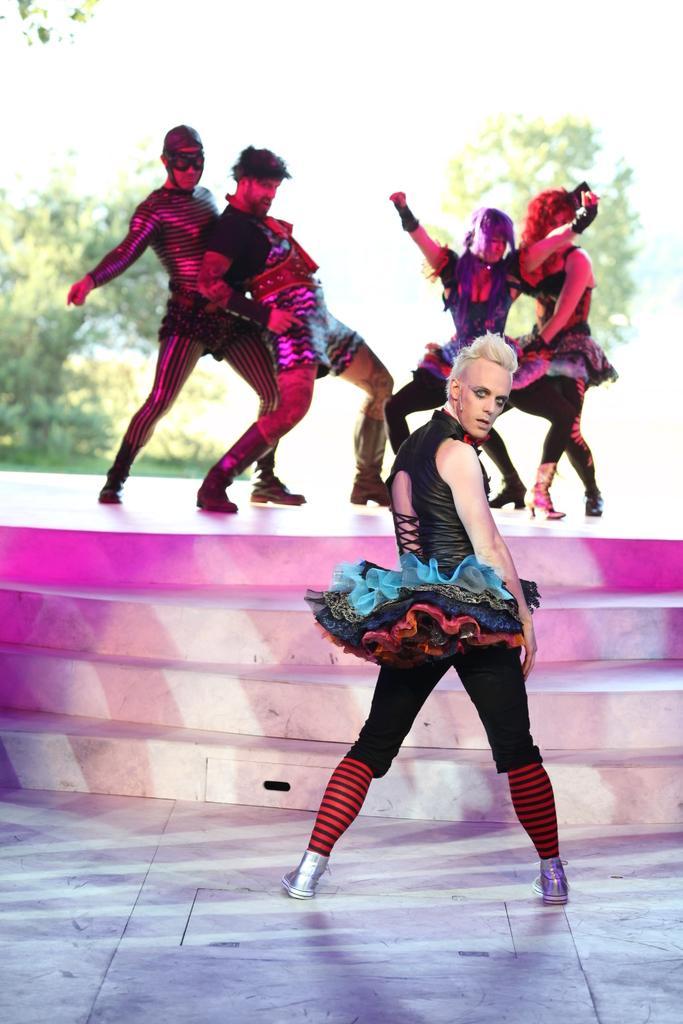How would you summarize this image in a sentence or two? In this image we can see people wearing costumes and there are stairs. In the background there are trees. 